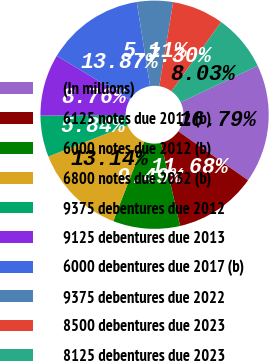Convert chart. <chart><loc_0><loc_0><loc_500><loc_500><pie_chart><fcel>(In millions)<fcel>6125 notes due 2012 (b)<fcel>6000 notes due 2012 (b)<fcel>6800 notes due 2032 (b)<fcel>9375 debentures due 2012<fcel>9125 debentures due 2013<fcel>6000 debentures due 2017 (b)<fcel>9375 debentures due 2022<fcel>8500 debentures due 2023<fcel>8125 debentures due 2023<nl><fcel>16.79%<fcel>11.68%<fcel>9.49%<fcel>13.14%<fcel>5.84%<fcel>8.76%<fcel>13.87%<fcel>5.11%<fcel>7.3%<fcel>8.03%<nl></chart> 